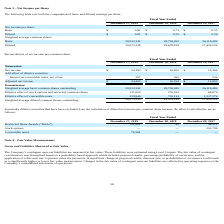From Chefs Wharehouse's financial document, What is the net income per basic share for fiscal years 2019, 2018 and 2017 respectively? The document contains multiple relevant values: $0.82, $0.71, $0.55. From the document: "Basic $ 0.82 $ 0.71 $ 0.55 Basic $ 0.82 $ 0.71 $ 0.55 Basic $ 0.82 $ 0.71 $ 0.55..." Also, What is the net income per diluted share for fiscal years 2019, 2018 and 2017 respectively? The document contains multiple relevant values: $0.81, $0.70, $0.54. From the document: "Diluted $ 0.81 $ 0.70 $ 0.54 Diluted $ 0.81 $ 0.70 $ 0.54 Diluted $ 0.81 $ 0.70 $ 0.54..." Also, What information does the table set forth? the computation of basic and diluted earnings per share. The document states: "t Income per Share The following table sets forth the computation of basic and diluted earnings per share:..." Additionally, Which year has the highest net income per basic share? According to the financial document, 2019. The relevant text states: "December 27, 2019 December 28, 2018 December 29, 2017..." Also, can you calculate: What is the average Net income per basic share from 2017-2019? To answer this question, I need to perform calculations using the financial data. The calculation is: (0.82+ 0.71+ 0.55)/3, which equals 0.69. This is based on the information: "Basic $ 0.82 $ 0.71 $ 0.55 Basic $ 0.82 $ 0.71 $ 0.55 Basic $ 0.82 $ 0.71 $ 0.55..." The key data points involved are: 0.55, 0.71, 0.82. Also, can you calculate: What is the change in net income per diluted share between 2018 and 2019? Based on the calculation: 0.81-0.70, the result is 0.11. This is based on the information: "Diluted $ 0.81 $ 0.70 $ 0.54 Diluted $ 0.81 $ 0.70 $ 0.54..." The key data points involved are: 0.70, 0.81. 